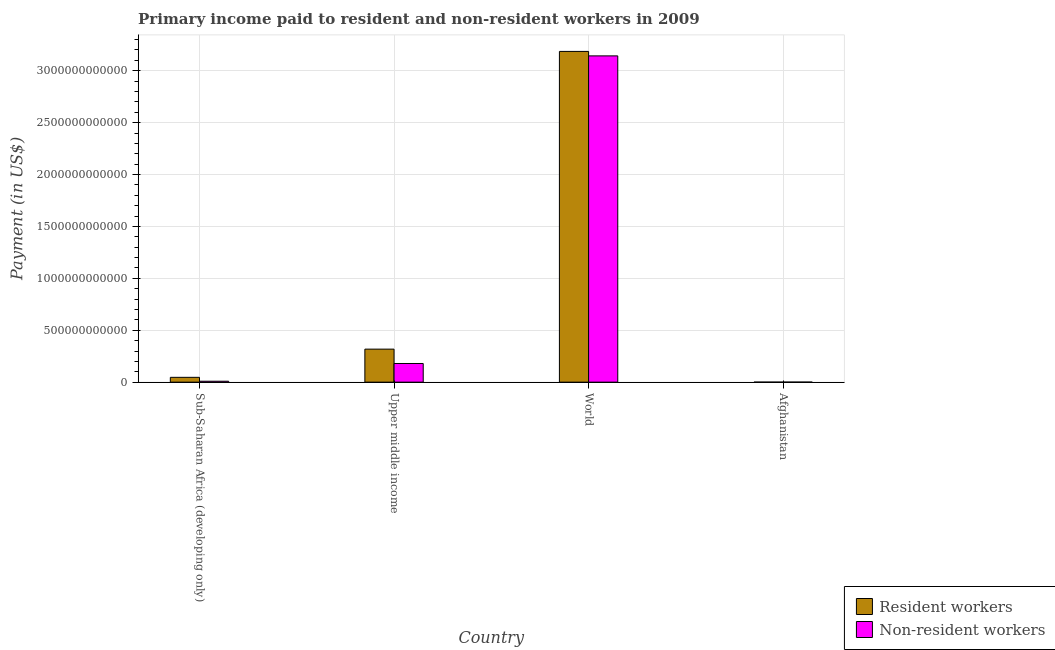Are the number of bars on each tick of the X-axis equal?
Keep it short and to the point. Yes. How many bars are there on the 4th tick from the left?
Provide a short and direct response. 2. How many bars are there on the 3rd tick from the right?
Your answer should be compact. 2. What is the label of the 4th group of bars from the left?
Your answer should be compact. Afghanistan. In how many cases, is the number of bars for a given country not equal to the number of legend labels?
Offer a very short reply. 0. What is the payment made to resident workers in Sub-Saharan Africa (developing only)?
Your answer should be compact. 4.64e+1. Across all countries, what is the maximum payment made to resident workers?
Ensure brevity in your answer.  3.19e+12. Across all countries, what is the minimum payment made to resident workers?
Your answer should be very brief. 1.66e+08. In which country was the payment made to resident workers maximum?
Your answer should be compact. World. In which country was the payment made to non-resident workers minimum?
Your answer should be compact. Afghanistan. What is the total payment made to non-resident workers in the graph?
Make the answer very short. 3.33e+12. What is the difference between the payment made to non-resident workers in Afghanistan and that in World?
Keep it short and to the point. -3.14e+12. What is the difference between the payment made to non-resident workers in Sub-Saharan Africa (developing only) and the payment made to resident workers in Upper middle income?
Provide a short and direct response. -3.09e+11. What is the average payment made to non-resident workers per country?
Provide a short and direct response. 8.33e+11. What is the difference between the payment made to resident workers and payment made to non-resident workers in Sub-Saharan Africa (developing only)?
Give a very brief answer. 3.75e+1. What is the ratio of the payment made to non-resident workers in Upper middle income to that in World?
Your answer should be very brief. 0.06. What is the difference between the highest and the second highest payment made to resident workers?
Keep it short and to the point. 2.87e+12. What is the difference between the highest and the lowest payment made to non-resident workers?
Provide a short and direct response. 3.14e+12. What does the 1st bar from the left in Sub-Saharan Africa (developing only) represents?
Offer a terse response. Resident workers. What does the 1st bar from the right in Upper middle income represents?
Your answer should be very brief. Non-resident workers. Are all the bars in the graph horizontal?
Your answer should be very brief. No. How many countries are there in the graph?
Keep it short and to the point. 4. What is the difference between two consecutive major ticks on the Y-axis?
Offer a very short reply. 5.00e+11. Are the values on the major ticks of Y-axis written in scientific E-notation?
Keep it short and to the point. No. Does the graph contain any zero values?
Offer a terse response. No. Does the graph contain grids?
Provide a succinct answer. Yes. Where does the legend appear in the graph?
Offer a very short reply. Bottom right. What is the title of the graph?
Provide a succinct answer. Primary income paid to resident and non-resident workers in 2009. What is the label or title of the Y-axis?
Your response must be concise. Payment (in US$). What is the Payment (in US$) in Resident workers in Sub-Saharan Africa (developing only)?
Keep it short and to the point. 4.64e+1. What is the Payment (in US$) in Non-resident workers in Sub-Saharan Africa (developing only)?
Give a very brief answer. 8.85e+09. What is the Payment (in US$) of Resident workers in Upper middle income?
Provide a short and direct response. 3.18e+11. What is the Payment (in US$) of Non-resident workers in Upper middle income?
Make the answer very short. 1.80e+11. What is the Payment (in US$) in Resident workers in World?
Provide a succinct answer. 3.19e+12. What is the Payment (in US$) in Non-resident workers in World?
Offer a very short reply. 3.14e+12. What is the Payment (in US$) in Resident workers in Afghanistan?
Keep it short and to the point. 1.66e+08. What is the Payment (in US$) of Non-resident workers in Afghanistan?
Ensure brevity in your answer.  2.46e+08. Across all countries, what is the maximum Payment (in US$) in Resident workers?
Provide a short and direct response. 3.19e+12. Across all countries, what is the maximum Payment (in US$) of Non-resident workers?
Give a very brief answer. 3.14e+12. Across all countries, what is the minimum Payment (in US$) of Resident workers?
Provide a short and direct response. 1.66e+08. Across all countries, what is the minimum Payment (in US$) in Non-resident workers?
Keep it short and to the point. 2.46e+08. What is the total Payment (in US$) in Resident workers in the graph?
Give a very brief answer. 3.55e+12. What is the total Payment (in US$) of Non-resident workers in the graph?
Keep it short and to the point. 3.33e+12. What is the difference between the Payment (in US$) in Resident workers in Sub-Saharan Africa (developing only) and that in Upper middle income?
Your answer should be very brief. -2.72e+11. What is the difference between the Payment (in US$) of Non-resident workers in Sub-Saharan Africa (developing only) and that in Upper middle income?
Offer a very short reply. -1.71e+11. What is the difference between the Payment (in US$) of Resident workers in Sub-Saharan Africa (developing only) and that in World?
Keep it short and to the point. -3.14e+12. What is the difference between the Payment (in US$) in Non-resident workers in Sub-Saharan Africa (developing only) and that in World?
Offer a very short reply. -3.13e+12. What is the difference between the Payment (in US$) of Resident workers in Sub-Saharan Africa (developing only) and that in Afghanistan?
Your answer should be very brief. 4.62e+1. What is the difference between the Payment (in US$) in Non-resident workers in Sub-Saharan Africa (developing only) and that in Afghanistan?
Offer a very short reply. 8.60e+09. What is the difference between the Payment (in US$) of Resident workers in Upper middle income and that in World?
Provide a short and direct response. -2.87e+12. What is the difference between the Payment (in US$) of Non-resident workers in Upper middle income and that in World?
Your answer should be very brief. -2.96e+12. What is the difference between the Payment (in US$) of Resident workers in Upper middle income and that in Afghanistan?
Keep it short and to the point. 3.18e+11. What is the difference between the Payment (in US$) of Non-resident workers in Upper middle income and that in Afghanistan?
Keep it short and to the point. 1.79e+11. What is the difference between the Payment (in US$) in Resident workers in World and that in Afghanistan?
Make the answer very short. 3.19e+12. What is the difference between the Payment (in US$) of Non-resident workers in World and that in Afghanistan?
Provide a succinct answer. 3.14e+12. What is the difference between the Payment (in US$) in Resident workers in Sub-Saharan Africa (developing only) and the Payment (in US$) in Non-resident workers in Upper middle income?
Ensure brevity in your answer.  -1.33e+11. What is the difference between the Payment (in US$) of Resident workers in Sub-Saharan Africa (developing only) and the Payment (in US$) of Non-resident workers in World?
Offer a very short reply. -3.10e+12. What is the difference between the Payment (in US$) in Resident workers in Sub-Saharan Africa (developing only) and the Payment (in US$) in Non-resident workers in Afghanistan?
Your response must be concise. 4.61e+1. What is the difference between the Payment (in US$) of Resident workers in Upper middle income and the Payment (in US$) of Non-resident workers in World?
Your response must be concise. -2.82e+12. What is the difference between the Payment (in US$) of Resident workers in Upper middle income and the Payment (in US$) of Non-resident workers in Afghanistan?
Give a very brief answer. 3.18e+11. What is the difference between the Payment (in US$) of Resident workers in World and the Payment (in US$) of Non-resident workers in Afghanistan?
Offer a terse response. 3.19e+12. What is the average Payment (in US$) in Resident workers per country?
Make the answer very short. 8.88e+11. What is the average Payment (in US$) of Non-resident workers per country?
Provide a short and direct response. 8.33e+11. What is the difference between the Payment (in US$) in Resident workers and Payment (in US$) in Non-resident workers in Sub-Saharan Africa (developing only)?
Keep it short and to the point. 3.75e+1. What is the difference between the Payment (in US$) of Resident workers and Payment (in US$) of Non-resident workers in Upper middle income?
Provide a short and direct response. 1.38e+11. What is the difference between the Payment (in US$) of Resident workers and Payment (in US$) of Non-resident workers in World?
Your answer should be compact. 4.30e+1. What is the difference between the Payment (in US$) in Resident workers and Payment (in US$) in Non-resident workers in Afghanistan?
Keep it short and to the point. -8.03e+07. What is the ratio of the Payment (in US$) of Resident workers in Sub-Saharan Africa (developing only) to that in Upper middle income?
Your response must be concise. 0.15. What is the ratio of the Payment (in US$) of Non-resident workers in Sub-Saharan Africa (developing only) to that in Upper middle income?
Your response must be concise. 0.05. What is the ratio of the Payment (in US$) in Resident workers in Sub-Saharan Africa (developing only) to that in World?
Offer a terse response. 0.01. What is the ratio of the Payment (in US$) in Non-resident workers in Sub-Saharan Africa (developing only) to that in World?
Offer a very short reply. 0. What is the ratio of the Payment (in US$) in Resident workers in Sub-Saharan Africa (developing only) to that in Afghanistan?
Offer a very short reply. 279.62. What is the ratio of the Payment (in US$) in Non-resident workers in Sub-Saharan Africa (developing only) to that in Afghanistan?
Provide a short and direct response. 35.93. What is the ratio of the Payment (in US$) of Resident workers in Upper middle income to that in World?
Give a very brief answer. 0.1. What is the ratio of the Payment (in US$) of Non-resident workers in Upper middle income to that in World?
Offer a terse response. 0.06. What is the ratio of the Payment (in US$) in Resident workers in Upper middle income to that in Afghanistan?
Offer a very short reply. 1918.04. What is the ratio of the Payment (in US$) in Non-resident workers in Upper middle income to that in Afghanistan?
Give a very brief answer. 729.96. What is the ratio of the Payment (in US$) of Resident workers in World to that in Afghanistan?
Your answer should be compact. 1.92e+04. What is the ratio of the Payment (in US$) of Non-resident workers in World to that in Afghanistan?
Provide a succinct answer. 1.28e+04. What is the difference between the highest and the second highest Payment (in US$) in Resident workers?
Make the answer very short. 2.87e+12. What is the difference between the highest and the second highest Payment (in US$) in Non-resident workers?
Your answer should be compact. 2.96e+12. What is the difference between the highest and the lowest Payment (in US$) of Resident workers?
Offer a terse response. 3.19e+12. What is the difference between the highest and the lowest Payment (in US$) in Non-resident workers?
Provide a succinct answer. 3.14e+12. 